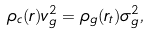<formula> <loc_0><loc_0><loc_500><loc_500>\rho _ { c } ( r ) v _ { g } ^ { 2 } = \rho _ { g } ( r _ { t } ) \sigma _ { g } ^ { 2 } ,</formula> 